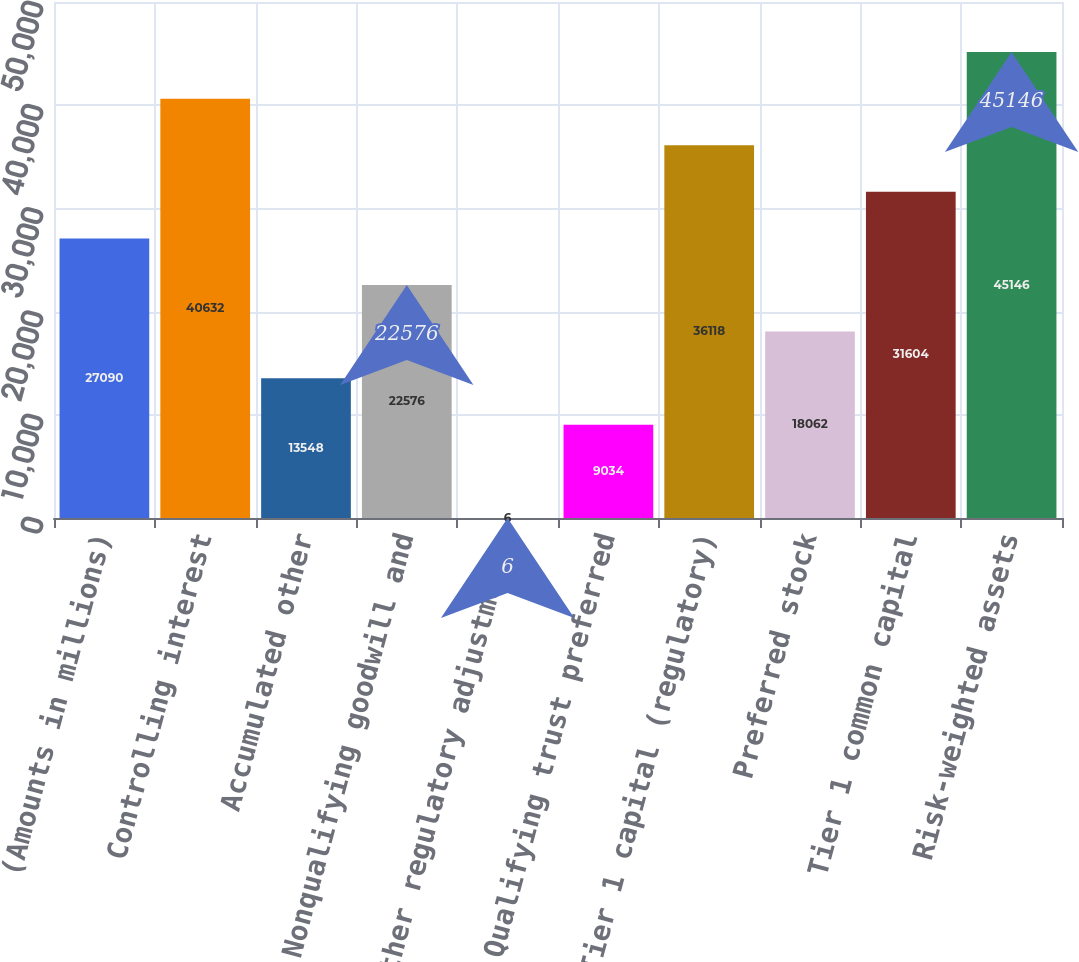Convert chart. <chart><loc_0><loc_0><loc_500><loc_500><bar_chart><fcel>(Amounts in millions)<fcel>Controlling interest<fcel>Accumulated other<fcel>Nonqualifying goodwill and<fcel>Other regulatory adjustments<fcel>Qualifying trust preferred<fcel>Tier 1 capital (regulatory)<fcel>Preferred stock<fcel>Tier 1 common capital<fcel>Risk-weighted assets<nl><fcel>27090<fcel>40632<fcel>13548<fcel>22576<fcel>6<fcel>9034<fcel>36118<fcel>18062<fcel>31604<fcel>45146<nl></chart> 